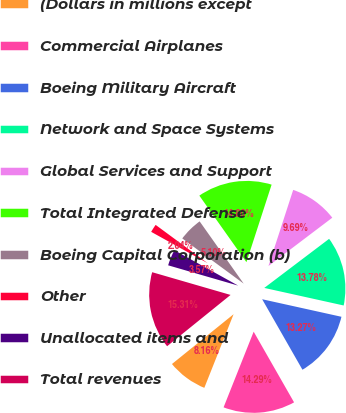<chart> <loc_0><loc_0><loc_500><loc_500><pie_chart><fcel>(Dollars in millions except<fcel>Commercial Airplanes<fcel>Boeing Military Aircraft<fcel>Network and Space Systems<fcel>Global Services and Support<fcel>Total Integrated Defense<fcel>Boeing Capital Corporation (b)<fcel>Other<fcel>Unallocated items and<fcel>Total revenues<nl><fcel>8.16%<fcel>14.29%<fcel>13.27%<fcel>13.78%<fcel>9.69%<fcel>14.8%<fcel>5.1%<fcel>2.04%<fcel>3.57%<fcel>15.31%<nl></chart> 